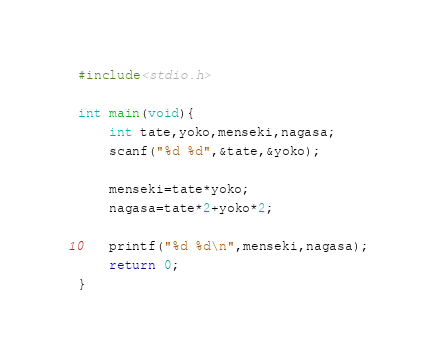Convert code to text. <code><loc_0><loc_0><loc_500><loc_500><_C_>#include<stdio.h>

int main(void){
	int tate,yoko,menseki,nagasa;
	scanf("%d %d",&tate,&yoko);
	
	menseki=tate*yoko;
	nagasa=tate*2+yoko*2;
	
	printf("%d %d\n",menseki,nagasa);
	return 0;
}</code> 